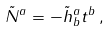<formula> <loc_0><loc_0><loc_500><loc_500>\tilde { N } ^ { a } = - { \tilde { h } ^ { a } } _ { b } t ^ { b } \, ,</formula> 